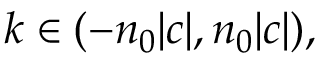<formula> <loc_0><loc_0><loc_500><loc_500>k \in ( - n _ { 0 } | c | , n _ { 0 } | c | ) ,</formula> 